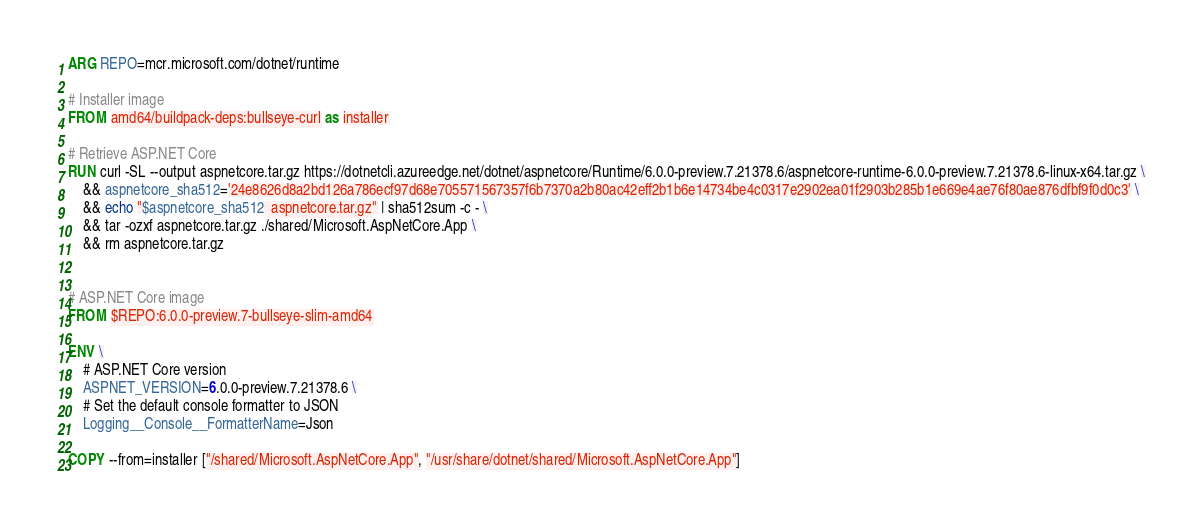<code> <loc_0><loc_0><loc_500><loc_500><_Dockerfile_>ARG REPO=mcr.microsoft.com/dotnet/runtime

# Installer image
FROM amd64/buildpack-deps:bullseye-curl as installer

# Retrieve ASP.NET Core
RUN curl -SL --output aspnetcore.tar.gz https://dotnetcli.azureedge.net/dotnet/aspnetcore/Runtime/6.0.0-preview.7.21378.6/aspnetcore-runtime-6.0.0-preview.7.21378.6-linux-x64.tar.gz \
    && aspnetcore_sha512='24e8626d8a2bd126a786ecf97d68e705571567357f6b7370a2b80ac42eff2b1b6e14734be4c0317e2902ea01f2903b285b1e669e4ae76f80ae876dfbf9f0d0c3' \
    && echo "$aspnetcore_sha512  aspnetcore.tar.gz" | sha512sum -c - \
    && tar -ozxf aspnetcore.tar.gz ./shared/Microsoft.AspNetCore.App \
    && rm aspnetcore.tar.gz


# ASP.NET Core image
FROM $REPO:6.0.0-preview.7-bullseye-slim-amd64

ENV \
    # ASP.NET Core version
    ASPNET_VERSION=6.0.0-preview.7.21378.6 \
    # Set the default console formatter to JSON
    Logging__Console__FormatterName=Json

COPY --from=installer ["/shared/Microsoft.AspNetCore.App", "/usr/share/dotnet/shared/Microsoft.AspNetCore.App"]
</code> 